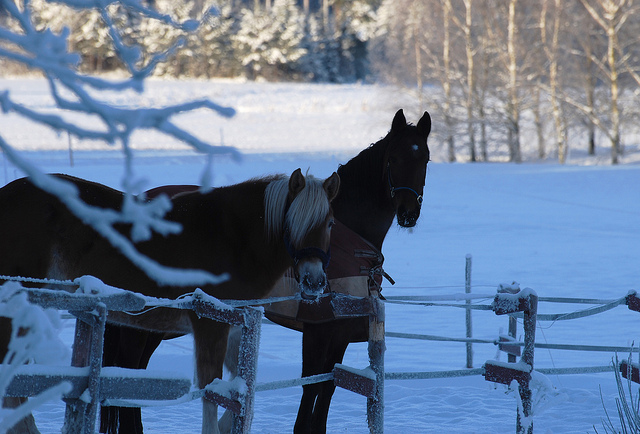What could be the significance of the fence in the image? The fence serves as a boundary for the horses, keeping them within a designated area. It's also a rustic element that adds to the pastoral charm of the scene, emphasizing the rural setting. Does the image indicate any human presence? There is no direct human presence observable in the image. However, the existence of the fence and the fact that the horses are wearing harnesses suggest that humans are involved in the care and management of the area. 